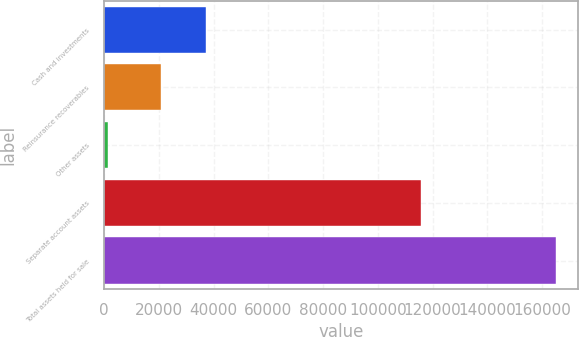<chart> <loc_0><loc_0><loc_500><loc_500><bar_chart><fcel>Cash and investments<fcel>Reinsurance recoverables<fcel>Other assets<fcel>Separate account assets<fcel>Total assets held for sale<nl><fcel>37134.7<fcel>20785<fcel>1439<fcel>115834<fcel>164936<nl></chart> 